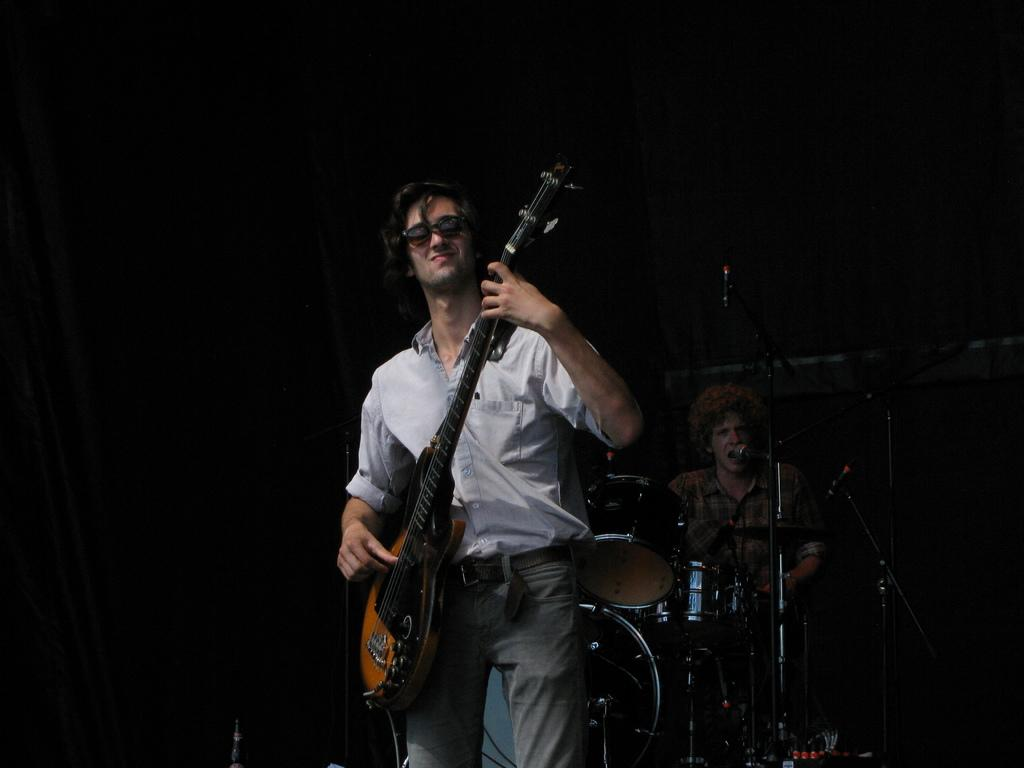What is the main activity being performed by the people in the image? The people in the image are playing musical instruments, specifically a guitar and drums. Is there any vocal accompaniment in the image? Yes, the person playing drums is also singing a song. What is the person singing holding in their hand? The person singing is holding a microphone. What type of business is being conducted in the image? There is no indication of any business being conducted in the image; the image shows people playing musical instruments and singing. What disease is the person playing drums suffering from in the image? There is no information about any disease in the image; it shows people playing music and singing. 